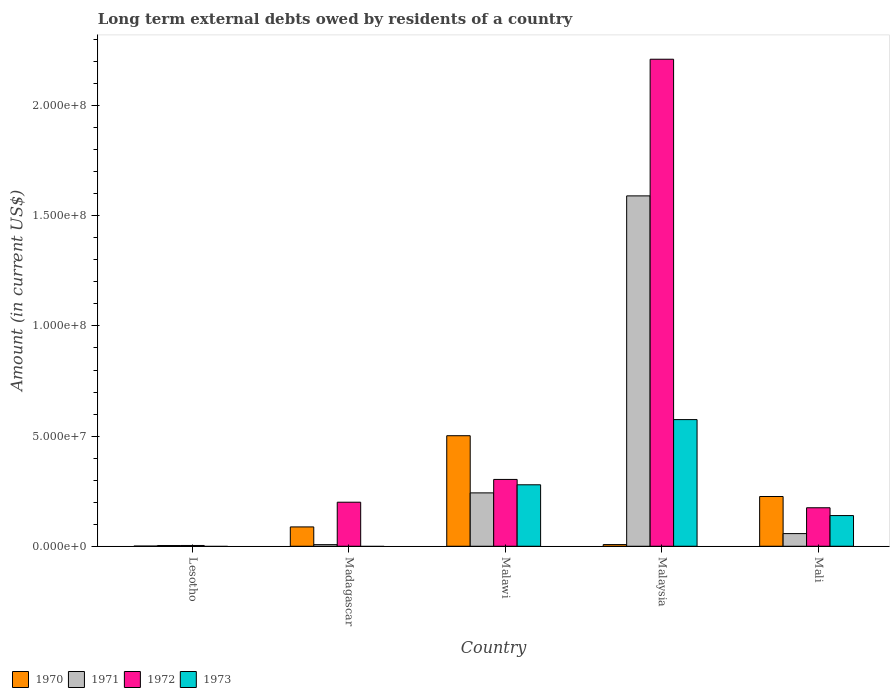How many different coloured bars are there?
Offer a very short reply. 4. How many bars are there on the 1st tick from the left?
Offer a terse response. 3. How many bars are there on the 3rd tick from the right?
Your answer should be very brief. 4. What is the label of the 3rd group of bars from the left?
Keep it short and to the point. Malawi. What is the amount of long-term external debts owed by residents in 1972 in Malaysia?
Make the answer very short. 2.21e+08. Across all countries, what is the maximum amount of long-term external debts owed by residents in 1973?
Your response must be concise. 5.75e+07. Across all countries, what is the minimum amount of long-term external debts owed by residents in 1973?
Your answer should be compact. 0. In which country was the amount of long-term external debts owed by residents in 1972 maximum?
Your answer should be compact. Malaysia. What is the total amount of long-term external debts owed by residents in 1970 in the graph?
Make the answer very short. 8.24e+07. What is the difference between the amount of long-term external debts owed by residents in 1972 in Malawi and that in Mali?
Keep it short and to the point. 1.29e+07. What is the difference between the amount of long-term external debts owed by residents in 1973 in Malawi and the amount of long-term external debts owed by residents in 1970 in Lesotho?
Your answer should be very brief. 2.78e+07. What is the average amount of long-term external debts owed by residents in 1972 per country?
Provide a succinct answer. 5.78e+07. What is the difference between the amount of long-term external debts owed by residents of/in 1971 and amount of long-term external debts owed by residents of/in 1970 in Mali?
Provide a short and direct response. -1.68e+07. In how many countries, is the amount of long-term external debts owed by residents in 1971 greater than 30000000 US$?
Ensure brevity in your answer.  1. What is the ratio of the amount of long-term external debts owed by residents in 1970 in Lesotho to that in Malawi?
Ensure brevity in your answer.  0. Is the amount of long-term external debts owed by residents in 1973 in Malaysia less than that in Mali?
Give a very brief answer. No. What is the difference between the highest and the second highest amount of long-term external debts owed by residents in 1972?
Your response must be concise. 1.91e+08. What is the difference between the highest and the lowest amount of long-term external debts owed by residents in 1973?
Offer a terse response. 5.75e+07. How many countries are there in the graph?
Offer a very short reply. 5. Are the values on the major ticks of Y-axis written in scientific E-notation?
Keep it short and to the point. Yes. Does the graph contain any zero values?
Give a very brief answer. Yes. Where does the legend appear in the graph?
Your response must be concise. Bottom left. What is the title of the graph?
Provide a succinct answer. Long term external debts owed by residents of a country. What is the label or title of the Y-axis?
Offer a very short reply. Amount (in current US$). What is the Amount (in current US$) of 1970 in Lesotho?
Offer a terse response. 7.60e+04. What is the Amount (in current US$) in 1971 in Lesotho?
Make the answer very short. 3.26e+05. What is the Amount (in current US$) of 1972 in Lesotho?
Provide a short and direct response. 3.48e+05. What is the Amount (in current US$) of 1970 in Madagascar?
Offer a terse response. 8.78e+06. What is the Amount (in current US$) of 1971 in Madagascar?
Give a very brief answer. 7.30e+05. What is the Amount (in current US$) of 1972 in Madagascar?
Keep it short and to the point. 2.00e+07. What is the Amount (in current US$) of 1970 in Malawi?
Your response must be concise. 5.02e+07. What is the Amount (in current US$) of 1971 in Malawi?
Ensure brevity in your answer.  2.42e+07. What is the Amount (in current US$) in 1972 in Malawi?
Keep it short and to the point. 3.03e+07. What is the Amount (in current US$) of 1973 in Malawi?
Offer a terse response. 2.79e+07. What is the Amount (in current US$) of 1970 in Malaysia?
Your response must be concise. 7.56e+05. What is the Amount (in current US$) in 1971 in Malaysia?
Offer a very short reply. 1.59e+08. What is the Amount (in current US$) in 1972 in Malaysia?
Offer a terse response. 2.21e+08. What is the Amount (in current US$) in 1973 in Malaysia?
Make the answer very short. 5.75e+07. What is the Amount (in current US$) in 1970 in Mali?
Ensure brevity in your answer.  2.26e+07. What is the Amount (in current US$) of 1971 in Mali?
Provide a short and direct response. 5.74e+06. What is the Amount (in current US$) of 1972 in Mali?
Give a very brief answer. 1.75e+07. What is the Amount (in current US$) of 1973 in Mali?
Give a very brief answer. 1.39e+07. Across all countries, what is the maximum Amount (in current US$) in 1970?
Your response must be concise. 5.02e+07. Across all countries, what is the maximum Amount (in current US$) of 1971?
Your answer should be compact. 1.59e+08. Across all countries, what is the maximum Amount (in current US$) of 1972?
Offer a very short reply. 2.21e+08. Across all countries, what is the maximum Amount (in current US$) in 1973?
Give a very brief answer. 5.75e+07. Across all countries, what is the minimum Amount (in current US$) in 1970?
Your answer should be very brief. 7.60e+04. Across all countries, what is the minimum Amount (in current US$) in 1971?
Your answer should be very brief. 3.26e+05. Across all countries, what is the minimum Amount (in current US$) of 1972?
Make the answer very short. 3.48e+05. Across all countries, what is the minimum Amount (in current US$) of 1973?
Your answer should be compact. 0. What is the total Amount (in current US$) of 1970 in the graph?
Ensure brevity in your answer.  8.24e+07. What is the total Amount (in current US$) of 1971 in the graph?
Keep it short and to the point. 1.90e+08. What is the total Amount (in current US$) in 1972 in the graph?
Keep it short and to the point. 2.89e+08. What is the total Amount (in current US$) of 1973 in the graph?
Your answer should be compact. 9.93e+07. What is the difference between the Amount (in current US$) in 1970 in Lesotho and that in Madagascar?
Offer a terse response. -8.70e+06. What is the difference between the Amount (in current US$) of 1971 in Lesotho and that in Madagascar?
Offer a terse response. -4.04e+05. What is the difference between the Amount (in current US$) of 1972 in Lesotho and that in Madagascar?
Ensure brevity in your answer.  -1.96e+07. What is the difference between the Amount (in current US$) of 1970 in Lesotho and that in Malawi?
Offer a very short reply. -5.01e+07. What is the difference between the Amount (in current US$) of 1971 in Lesotho and that in Malawi?
Provide a succinct answer. -2.39e+07. What is the difference between the Amount (in current US$) in 1972 in Lesotho and that in Malawi?
Your answer should be very brief. -3.00e+07. What is the difference between the Amount (in current US$) in 1970 in Lesotho and that in Malaysia?
Provide a succinct answer. -6.80e+05. What is the difference between the Amount (in current US$) in 1971 in Lesotho and that in Malaysia?
Provide a succinct answer. -1.59e+08. What is the difference between the Amount (in current US$) in 1972 in Lesotho and that in Malaysia?
Provide a succinct answer. -2.21e+08. What is the difference between the Amount (in current US$) of 1970 in Lesotho and that in Mali?
Your answer should be very brief. -2.25e+07. What is the difference between the Amount (in current US$) of 1971 in Lesotho and that in Mali?
Your answer should be compact. -5.41e+06. What is the difference between the Amount (in current US$) of 1972 in Lesotho and that in Mali?
Your answer should be very brief. -1.71e+07. What is the difference between the Amount (in current US$) of 1970 in Madagascar and that in Malawi?
Keep it short and to the point. -4.14e+07. What is the difference between the Amount (in current US$) in 1971 in Madagascar and that in Malawi?
Your response must be concise. -2.35e+07. What is the difference between the Amount (in current US$) in 1972 in Madagascar and that in Malawi?
Give a very brief answer. -1.03e+07. What is the difference between the Amount (in current US$) in 1970 in Madagascar and that in Malaysia?
Offer a terse response. 8.02e+06. What is the difference between the Amount (in current US$) in 1971 in Madagascar and that in Malaysia?
Offer a very short reply. -1.58e+08. What is the difference between the Amount (in current US$) of 1972 in Madagascar and that in Malaysia?
Make the answer very short. -2.01e+08. What is the difference between the Amount (in current US$) in 1970 in Madagascar and that in Mali?
Your response must be concise. -1.38e+07. What is the difference between the Amount (in current US$) in 1971 in Madagascar and that in Mali?
Provide a succinct answer. -5.01e+06. What is the difference between the Amount (in current US$) in 1972 in Madagascar and that in Mali?
Give a very brief answer. 2.52e+06. What is the difference between the Amount (in current US$) in 1970 in Malawi and that in Malaysia?
Provide a succinct answer. 4.94e+07. What is the difference between the Amount (in current US$) in 1971 in Malawi and that in Malaysia?
Ensure brevity in your answer.  -1.35e+08. What is the difference between the Amount (in current US$) of 1972 in Malawi and that in Malaysia?
Give a very brief answer. -1.91e+08. What is the difference between the Amount (in current US$) in 1973 in Malawi and that in Malaysia?
Offer a very short reply. -2.96e+07. What is the difference between the Amount (in current US$) of 1970 in Malawi and that in Mali?
Ensure brevity in your answer.  2.76e+07. What is the difference between the Amount (in current US$) in 1971 in Malawi and that in Mali?
Keep it short and to the point. 1.85e+07. What is the difference between the Amount (in current US$) of 1972 in Malawi and that in Mali?
Your response must be concise. 1.29e+07. What is the difference between the Amount (in current US$) of 1973 in Malawi and that in Mali?
Provide a short and direct response. 1.40e+07. What is the difference between the Amount (in current US$) in 1970 in Malaysia and that in Mali?
Your answer should be very brief. -2.18e+07. What is the difference between the Amount (in current US$) of 1971 in Malaysia and that in Mali?
Provide a short and direct response. 1.53e+08. What is the difference between the Amount (in current US$) of 1972 in Malaysia and that in Mali?
Offer a terse response. 2.04e+08. What is the difference between the Amount (in current US$) of 1973 in Malaysia and that in Mali?
Keep it short and to the point. 4.36e+07. What is the difference between the Amount (in current US$) in 1970 in Lesotho and the Amount (in current US$) in 1971 in Madagascar?
Your answer should be compact. -6.54e+05. What is the difference between the Amount (in current US$) of 1970 in Lesotho and the Amount (in current US$) of 1972 in Madagascar?
Give a very brief answer. -1.99e+07. What is the difference between the Amount (in current US$) in 1971 in Lesotho and the Amount (in current US$) in 1972 in Madagascar?
Your answer should be compact. -1.97e+07. What is the difference between the Amount (in current US$) of 1970 in Lesotho and the Amount (in current US$) of 1971 in Malawi?
Keep it short and to the point. -2.42e+07. What is the difference between the Amount (in current US$) in 1970 in Lesotho and the Amount (in current US$) in 1972 in Malawi?
Your answer should be very brief. -3.03e+07. What is the difference between the Amount (in current US$) of 1970 in Lesotho and the Amount (in current US$) of 1973 in Malawi?
Your response must be concise. -2.78e+07. What is the difference between the Amount (in current US$) in 1971 in Lesotho and the Amount (in current US$) in 1972 in Malawi?
Offer a terse response. -3.00e+07. What is the difference between the Amount (in current US$) of 1971 in Lesotho and the Amount (in current US$) of 1973 in Malawi?
Ensure brevity in your answer.  -2.76e+07. What is the difference between the Amount (in current US$) of 1972 in Lesotho and the Amount (in current US$) of 1973 in Malawi?
Ensure brevity in your answer.  -2.76e+07. What is the difference between the Amount (in current US$) of 1970 in Lesotho and the Amount (in current US$) of 1971 in Malaysia?
Your answer should be very brief. -1.59e+08. What is the difference between the Amount (in current US$) in 1970 in Lesotho and the Amount (in current US$) in 1972 in Malaysia?
Keep it short and to the point. -2.21e+08. What is the difference between the Amount (in current US$) of 1970 in Lesotho and the Amount (in current US$) of 1973 in Malaysia?
Your answer should be compact. -5.74e+07. What is the difference between the Amount (in current US$) in 1971 in Lesotho and the Amount (in current US$) in 1972 in Malaysia?
Give a very brief answer. -2.21e+08. What is the difference between the Amount (in current US$) of 1971 in Lesotho and the Amount (in current US$) of 1973 in Malaysia?
Provide a short and direct response. -5.72e+07. What is the difference between the Amount (in current US$) in 1972 in Lesotho and the Amount (in current US$) in 1973 in Malaysia?
Your answer should be compact. -5.71e+07. What is the difference between the Amount (in current US$) of 1970 in Lesotho and the Amount (in current US$) of 1971 in Mali?
Your answer should be very brief. -5.66e+06. What is the difference between the Amount (in current US$) in 1970 in Lesotho and the Amount (in current US$) in 1972 in Mali?
Provide a succinct answer. -1.74e+07. What is the difference between the Amount (in current US$) in 1970 in Lesotho and the Amount (in current US$) in 1973 in Mali?
Provide a succinct answer. -1.39e+07. What is the difference between the Amount (in current US$) of 1971 in Lesotho and the Amount (in current US$) of 1972 in Mali?
Offer a very short reply. -1.71e+07. What is the difference between the Amount (in current US$) in 1971 in Lesotho and the Amount (in current US$) in 1973 in Mali?
Provide a short and direct response. -1.36e+07. What is the difference between the Amount (in current US$) of 1972 in Lesotho and the Amount (in current US$) of 1973 in Mali?
Your response must be concise. -1.36e+07. What is the difference between the Amount (in current US$) of 1970 in Madagascar and the Amount (in current US$) of 1971 in Malawi?
Give a very brief answer. -1.55e+07. What is the difference between the Amount (in current US$) in 1970 in Madagascar and the Amount (in current US$) in 1972 in Malawi?
Give a very brief answer. -2.16e+07. What is the difference between the Amount (in current US$) in 1970 in Madagascar and the Amount (in current US$) in 1973 in Malawi?
Keep it short and to the point. -1.91e+07. What is the difference between the Amount (in current US$) of 1971 in Madagascar and the Amount (in current US$) of 1972 in Malawi?
Provide a short and direct response. -2.96e+07. What is the difference between the Amount (in current US$) in 1971 in Madagascar and the Amount (in current US$) in 1973 in Malawi?
Your response must be concise. -2.72e+07. What is the difference between the Amount (in current US$) of 1972 in Madagascar and the Amount (in current US$) of 1973 in Malawi?
Your answer should be very brief. -7.91e+06. What is the difference between the Amount (in current US$) in 1970 in Madagascar and the Amount (in current US$) in 1971 in Malaysia?
Offer a terse response. -1.50e+08. What is the difference between the Amount (in current US$) of 1970 in Madagascar and the Amount (in current US$) of 1972 in Malaysia?
Your response must be concise. -2.12e+08. What is the difference between the Amount (in current US$) in 1970 in Madagascar and the Amount (in current US$) in 1973 in Malaysia?
Ensure brevity in your answer.  -4.87e+07. What is the difference between the Amount (in current US$) of 1971 in Madagascar and the Amount (in current US$) of 1972 in Malaysia?
Keep it short and to the point. -2.20e+08. What is the difference between the Amount (in current US$) of 1971 in Madagascar and the Amount (in current US$) of 1973 in Malaysia?
Ensure brevity in your answer.  -5.68e+07. What is the difference between the Amount (in current US$) in 1972 in Madagascar and the Amount (in current US$) in 1973 in Malaysia?
Offer a terse response. -3.75e+07. What is the difference between the Amount (in current US$) of 1970 in Madagascar and the Amount (in current US$) of 1971 in Mali?
Give a very brief answer. 3.04e+06. What is the difference between the Amount (in current US$) of 1970 in Madagascar and the Amount (in current US$) of 1972 in Mali?
Make the answer very short. -8.70e+06. What is the difference between the Amount (in current US$) in 1970 in Madagascar and the Amount (in current US$) in 1973 in Mali?
Offer a terse response. -5.15e+06. What is the difference between the Amount (in current US$) of 1971 in Madagascar and the Amount (in current US$) of 1972 in Mali?
Give a very brief answer. -1.67e+07. What is the difference between the Amount (in current US$) of 1971 in Madagascar and the Amount (in current US$) of 1973 in Mali?
Provide a succinct answer. -1.32e+07. What is the difference between the Amount (in current US$) of 1972 in Madagascar and the Amount (in current US$) of 1973 in Mali?
Your response must be concise. 6.06e+06. What is the difference between the Amount (in current US$) of 1970 in Malawi and the Amount (in current US$) of 1971 in Malaysia?
Ensure brevity in your answer.  -1.09e+08. What is the difference between the Amount (in current US$) of 1970 in Malawi and the Amount (in current US$) of 1972 in Malaysia?
Your answer should be very brief. -1.71e+08. What is the difference between the Amount (in current US$) in 1970 in Malawi and the Amount (in current US$) in 1973 in Malaysia?
Your response must be concise. -7.31e+06. What is the difference between the Amount (in current US$) of 1971 in Malawi and the Amount (in current US$) of 1972 in Malaysia?
Offer a very short reply. -1.97e+08. What is the difference between the Amount (in current US$) of 1971 in Malawi and the Amount (in current US$) of 1973 in Malaysia?
Your response must be concise. -3.33e+07. What is the difference between the Amount (in current US$) in 1972 in Malawi and the Amount (in current US$) in 1973 in Malaysia?
Offer a terse response. -2.72e+07. What is the difference between the Amount (in current US$) in 1970 in Malawi and the Amount (in current US$) in 1971 in Mali?
Your response must be concise. 4.44e+07. What is the difference between the Amount (in current US$) of 1970 in Malawi and the Amount (in current US$) of 1972 in Mali?
Offer a very short reply. 3.27e+07. What is the difference between the Amount (in current US$) in 1970 in Malawi and the Amount (in current US$) in 1973 in Mali?
Offer a terse response. 3.62e+07. What is the difference between the Amount (in current US$) in 1971 in Malawi and the Amount (in current US$) in 1972 in Mali?
Make the answer very short. 6.76e+06. What is the difference between the Amount (in current US$) in 1971 in Malawi and the Amount (in current US$) in 1973 in Mali?
Provide a succinct answer. 1.03e+07. What is the difference between the Amount (in current US$) in 1972 in Malawi and the Amount (in current US$) in 1973 in Mali?
Your answer should be compact. 1.64e+07. What is the difference between the Amount (in current US$) of 1970 in Malaysia and the Amount (in current US$) of 1971 in Mali?
Your response must be concise. -4.98e+06. What is the difference between the Amount (in current US$) of 1970 in Malaysia and the Amount (in current US$) of 1972 in Mali?
Offer a very short reply. -1.67e+07. What is the difference between the Amount (in current US$) of 1970 in Malaysia and the Amount (in current US$) of 1973 in Mali?
Offer a terse response. -1.32e+07. What is the difference between the Amount (in current US$) in 1971 in Malaysia and the Amount (in current US$) in 1972 in Mali?
Provide a short and direct response. 1.42e+08. What is the difference between the Amount (in current US$) of 1971 in Malaysia and the Amount (in current US$) of 1973 in Mali?
Your response must be concise. 1.45e+08. What is the difference between the Amount (in current US$) in 1972 in Malaysia and the Amount (in current US$) in 1973 in Mali?
Your answer should be very brief. 2.07e+08. What is the average Amount (in current US$) in 1970 per country?
Your response must be concise. 1.65e+07. What is the average Amount (in current US$) in 1971 per country?
Keep it short and to the point. 3.80e+07. What is the average Amount (in current US$) of 1972 per country?
Provide a succinct answer. 5.78e+07. What is the average Amount (in current US$) in 1973 per country?
Offer a terse response. 1.99e+07. What is the difference between the Amount (in current US$) in 1970 and Amount (in current US$) in 1971 in Lesotho?
Keep it short and to the point. -2.50e+05. What is the difference between the Amount (in current US$) in 1970 and Amount (in current US$) in 1972 in Lesotho?
Your answer should be very brief. -2.72e+05. What is the difference between the Amount (in current US$) in 1971 and Amount (in current US$) in 1972 in Lesotho?
Your answer should be compact. -2.20e+04. What is the difference between the Amount (in current US$) in 1970 and Amount (in current US$) in 1971 in Madagascar?
Ensure brevity in your answer.  8.04e+06. What is the difference between the Amount (in current US$) in 1970 and Amount (in current US$) in 1972 in Madagascar?
Make the answer very short. -1.12e+07. What is the difference between the Amount (in current US$) of 1971 and Amount (in current US$) of 1972 in Madagascar?
Offer a very short reply. -1.93e+07. What is the difference between the Amount (in current US$) of 1970 and Amount (in current US$) of 1971 in Malawi?
Your answer should be very brief. 2.59e+07. What is the difference between the Amount (in current US$) in 1970 and Amount (in current US$) in 1972 in Malawi?
Your answer should be very brief. 1.98e+07. What is the difference between the Amount (in current US$) in 1970 and Amount (in current US$) in 1973 in Malawi?
Offer a very short reply. 2.23e+07. What is the difference between the Amount (in current US$) of 1971 and Amount (in current US$) of 1972 in Malawi?
Your answer should be very brief. -6.11e+06. What is the difference between the Amount (in current US$) in 1971 and Amount (in current US$) in 1973 in Malawi?
Offer a terse response. -3.67e+06. What is the difference between the Amount (in current US$) of 1972 and Amount (in current US$) of 1973 in Malawi?
Provide a succinct answer. 2.43e+06. What is the difference between the Amount (in current US$) of 1970 and Amount (in current US$) of 1971 in Malaysia?
Your answer should be compact. -1.58e+08. What is the difference between the Amount (in current US$) of 1970 and Amount (in current US$) of 1972 in Malaysia?
Give a very brief answer. -2.20e+08. What is the difference between the Amount (in current US$) in 1970 and Amount (in current US$) in 1973 in Malaysia?
Your answer should be very brief. -5.67e+07. What is the difference between the Amount (in current US$) of 1971 and Amount (in current US$) of 1972 in Malaysia?
Keep it short and to the point. -6.20e+07. What is the difference between the Amount (in current US$) of 1971 and Amount (in current US$) of 1973 in Malaysia?
Make the answer very short. 1.02e+08. What is the difference between the Amount (in current US$) in 1972 and Amount (in current US$) in 1973 in Malaysia?
Keep it short and to the point. 1.64e+08. What is the difference between the Amount (in current US$) of 1970 and Amount (in current US$) of 1971 in Mali?
Give a very brief answer. 1.68e+07. What is the difference between the Amount (in current US$) in 1970 and Amount (in current US$) in 1972 in Mali?
Provide a short and direct response. 5.11e+06. What is the difference between the Amount (in current US$) in 1970 and Amount (in current US$) in 1973 in Mali?
Keep it short and to the point. 8.65e+06. What is the difference between the Amount (in current US$) in 1971 and Amount (in current US$) in 1972 in Mali?
Keep it short and to the point. -1.17e+07. What is the difference between the Amount (in current US$) in 1971 and Amount (in current US$) in 1973 in Mali?
Your response must be concise. -8.19e+06. What is the difference between the Amount (in current US$) of 1972 and Amount (in current US$) of 1973 in Mali?
Your response must be concise. 3.54e+06. What is the ratio of the Amount (in current US$) in 1970 in Lesotho to that in Madagascar?
Your answer should be compact. 0.01. What is the ratio of the Amount (in current US$) in 1971 in Lesotho to that in Madagascar?
Give a very brief answer. 0.45. What is the ratio of the Amount (in current US$) in 1972 in Lesotho to that in Madagascar?
Provide a succinct answer. 0.02. What is the ratio of the Amount (in current US$) of 1970 in Lesotho to that in Malawi?
Make the answer very short. 0. What is the ratio of the Amount (in current US$) of 1971 in Lesotho to that in Malawi?
Provide a succinct answer. 0.01. What is the ratio of the Amount (in current US$) in 1972 in Lesotho to that in Malawi?
Make the answer very short. 0.01. What is the ratio of the Amount (in current US$) in 1970 in Lesotho to that in Malaysia?
Your answer should be very brief. 0.1. What is the ratio of the Amount (in current US$) of 1971 in Lesotho to that in Malaysia?
Ensure brevity in your answer.  0. What is the ratio of the Amount (in current US$) in 1972 in Lesotho to that in Malaysia?
Offer a terse response. 0. What is the ratio of the Amount (in current US$) of 1970 in Lesotho to that in Mali?
Ensure brevity in your answer.  0. What is the ratio of the Amount (in current US$) of 1971 in Lesotho to that in Mali?
Your answer should be compact. 0.06. What is the ratio of the Amount (in current US$) in 1972 in Lesotho to that in Mali?
Ensure brevity in your answer.  0.02. What is the ratio of the Amount (in current US$) of 1970 in Madagascar to that in Malawi?
Offer a terse response. 0.17. What is the ratio of the Amount (in current US$) in 1971 in Madagascar to that in Malawi?
Offer a terse response. 0.03. What is the ratio of the Amount (in current US$) of 1972 in Madagascar to that in Malawi?
Provide a short and direct response. 0.66. What is the ratio of the Amount (in current US$) in 1970 in Madagascar to that in Malaysia?
Provide a succinct answer. 11.61. What is the ratio of the Amount (in current US$) in 1971 in Madagascar to that in Malaysia?
Your answer should be compact. 0. What is the ratio of the Amount (in current US$) of 1972 in Madagascar to that in Malaysia?
Provide a short and direct response. 0.09. What is the ratio of the Amount (in current US$) in 1970 in Madagascar to that in Mali?
Offer a terse response. 0.39. What is the ratio of the Amount (in current US$) of 1971 in Madagascar to that in Mali?
Keep it short and to the point. 0.13. What is the ratio of the Amount (in current US$) in 1972 in Madagascar to that in Mali?
Your response must be concise. 1.14. What is the ratio of the Amount (in current US$) in 1970 in Malawi to that in Malaysia?
Make the answer very short. 66.37. What is the ratio of the Amount (in current US$) in 1971 in Malawi to that in Malaysia?
Provide a succinct answer. 0.15. What is the ratio of the Amount (in current US$) in 1972 in Malawi to that in Malaysia?
Keep it short and to the point. 0.14. What is the ratio of the Amount (in current US$) in 1973 in Malawi to that in Malaysia?
Keep it short and to the point. 0.49. What is the ratio of the Amount (in current US$) in 1970 in Malawi to that in Mali?
Your answer should be compact. 2.22. What is the ratio of the Amount (in current US$) in 1971 in Malawi to that in Mali?
Give a very brief answer. 4.22. What is the ratio of the Amount (in current US$) in 1972 in Malawi to that in Mali?
Your response must be concise. 1.74. What is the ratio of the Amount (in current US$) in 1973 in Malawi to that in Mali?
Provide a succinct answer. 2. What is the ratio of the Amount (in current US$) of 1970 in Malaysia to that in Mali?
Offer a very short reply. 0.03. What is the ratio of the Amount (in current US$) of 1971 in Malaysia to that in Mali?
Provide a succinct answer. 27.71. What is the ratio of the Amount (in current US$) in 1972 in Malaysia to that in Mali?
Provide a succinct answer. 12.65. What is the ratio of the Amount (in current US$) of 1973 in Malaysia to that in Mali?
Offer a very short reply. 4.13. What is the difference between the highest and the second highest Amount (in current US$) of 1970?
Provide a succinct answer. 2.76e+07. What is the difference between the highest and the second highest Amount (in current US$) in 1971?
Offer a terse response. 1.35e+08. What is the difference between the highest and the second highest Amount (in current US$) of 1972?
Offer a very short reply. 1.91e+08. What is the difference between the highest and the second highest Amount (in current US$) of 1973?
Your response must be concise. 2.96e+07. What is the difference between the highest and the lowest Amount (in current US$) in 1970?
Provide a succinct answer. 5.01e+07. What is the difference between the highest and the lowest Amount (in current US$) of 1971?
Offer a very short reply. 1.59e+08. What is the difference between the highest and the lowest Amount (in current US$) in 1972?
Provide a succinct answer. 2.21e+08. What is the difference between the highest and the lowest Amount (in current US$) in 1973?
Offer a terse response. 5.75e+07. 